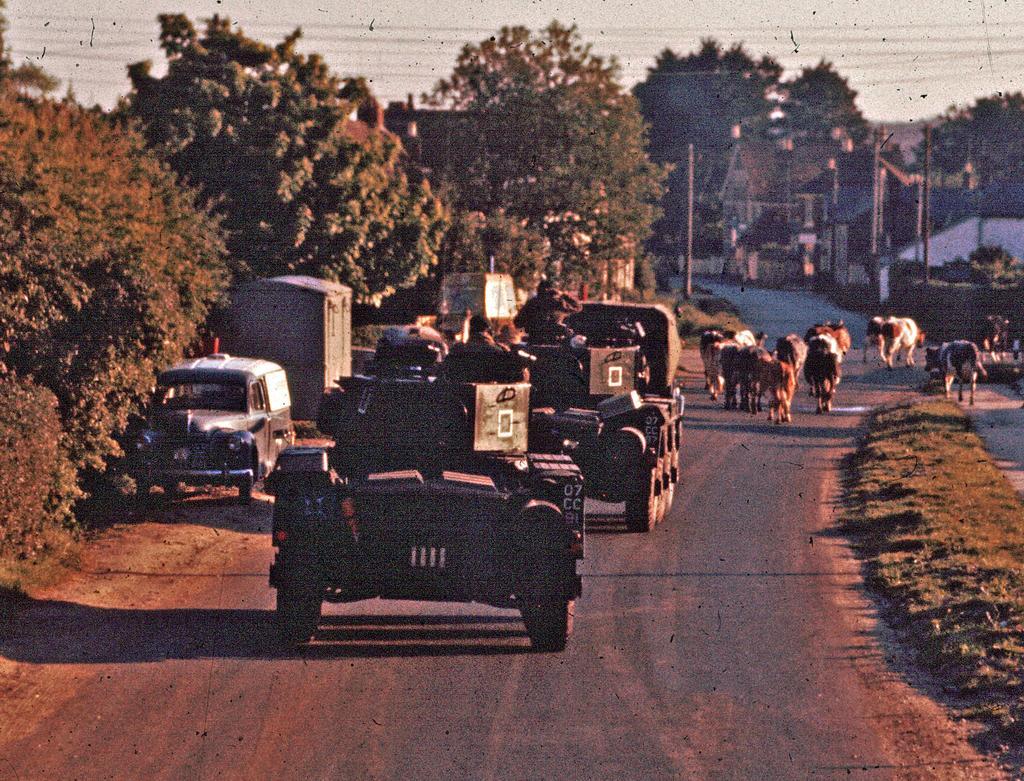Please provide a concise description of this image. This image is taken outdoors. At the bottom of the image there is a road and there is a ground with grass on it. In the background there are many trees and plants on the ground. There are a few houses. There are few poles with street lights. On the right side of the image there are a few cattle on the road. In the middle of the image a few vehicles are parked on the road and a few are moving on the road. At the top of the image there is the sky. 